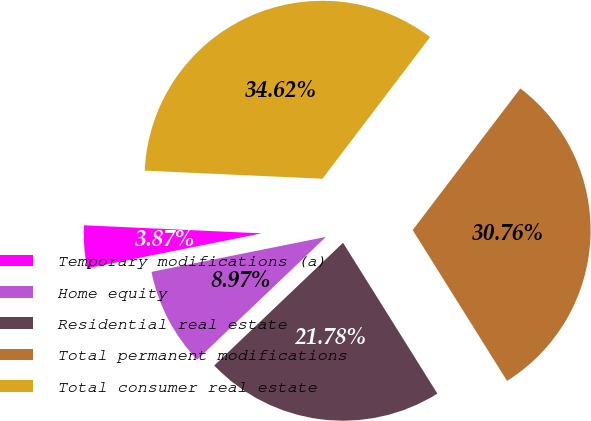Convert chart to OTSL. <chart><loc_0><loc_0><loc_500><loc_500><pie_chart><fcel>Temporary modifications (a)<fcel>Home equity<fcel>Residential real estate<fcel>Total permanent modifications<fcel>Total consumer real estate<nl><fcel>3.87%<fcel>8.97%<fcel>21.78%<fcel>30.76%<fcel>34.62%<nl></chart> 